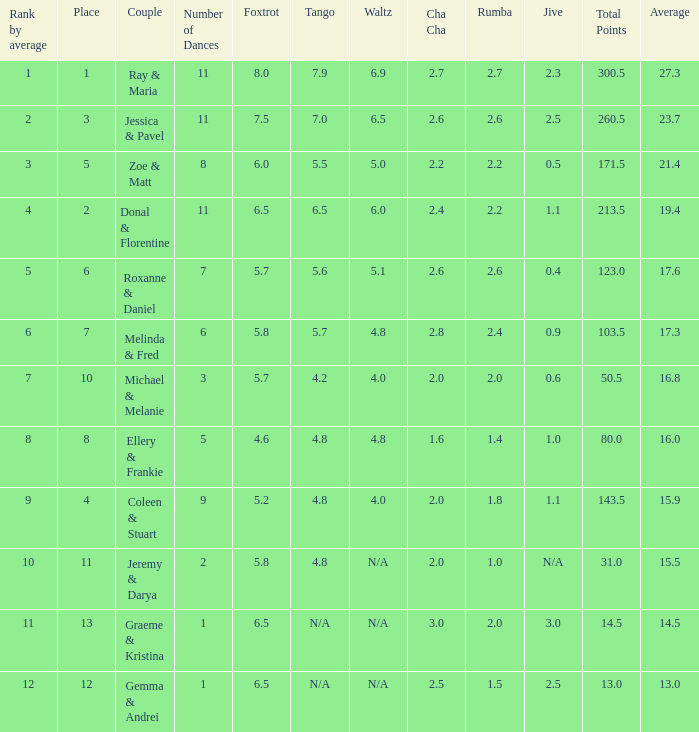If your rank by average is 9, what is the name of the couple? Coleen & Stuart. 